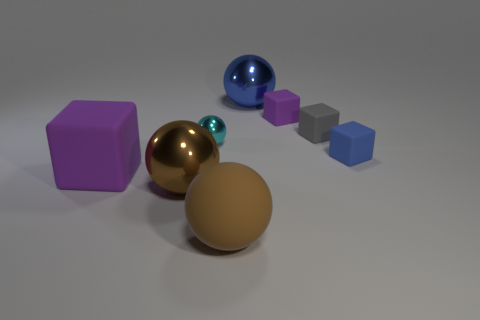Subtract 1 balls. How many balls are left? 3 Subtract all red cubes. Subtract all gray balls. How many cubes are left? 4 Add 1 big shiny objects. How many objects exist? 9 Subtract 1 cyan spheres. How many objects are left? 7 Subtract all small green metallic cylinders. Subtract all small blue objects. How many objects are left? 7 Add 1 blue matte objects. How many blue matte objects are left? 2 Add 1 large objects. How many large objects exist? 5 